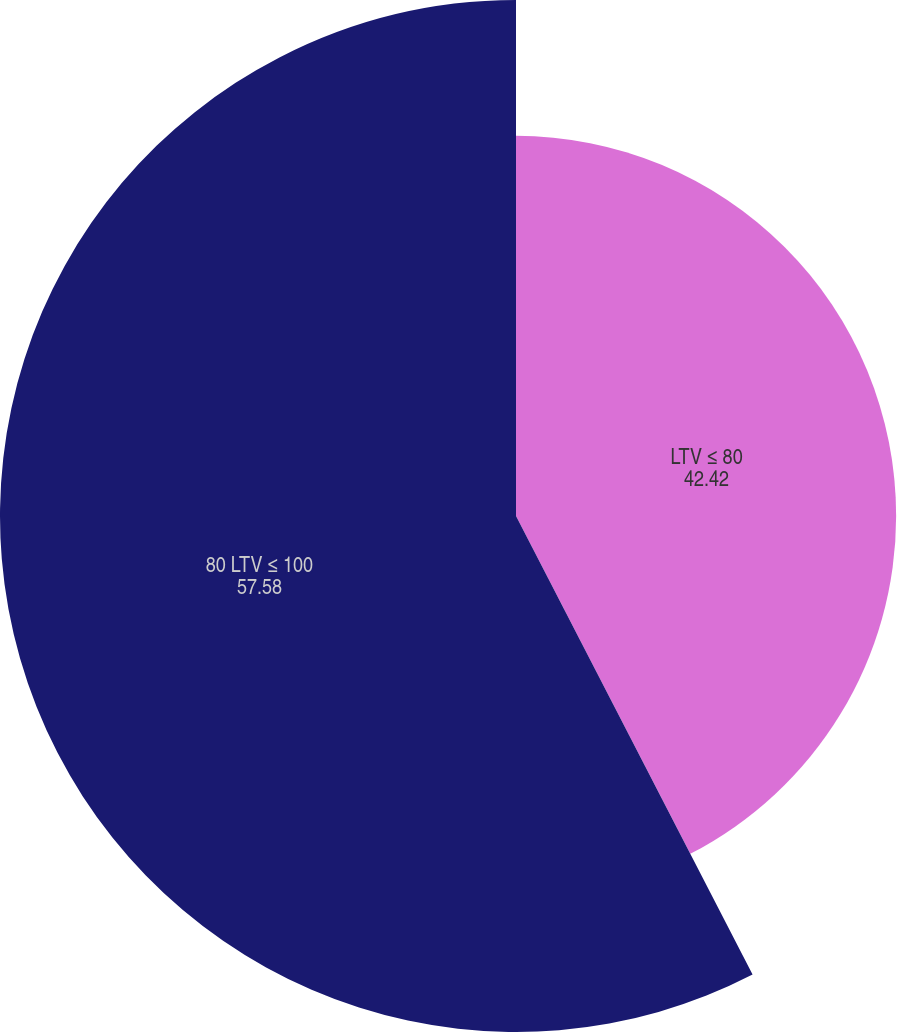Convert chart to OTSL. <chart><loc_0><loc_0><loc_500><loc_500><pie_chart><fcel>LTV ≤ 80<fcel>80 LTV ≤ 100<nl><fcel>42.42%<fcel>57.58%<nl></chart> 